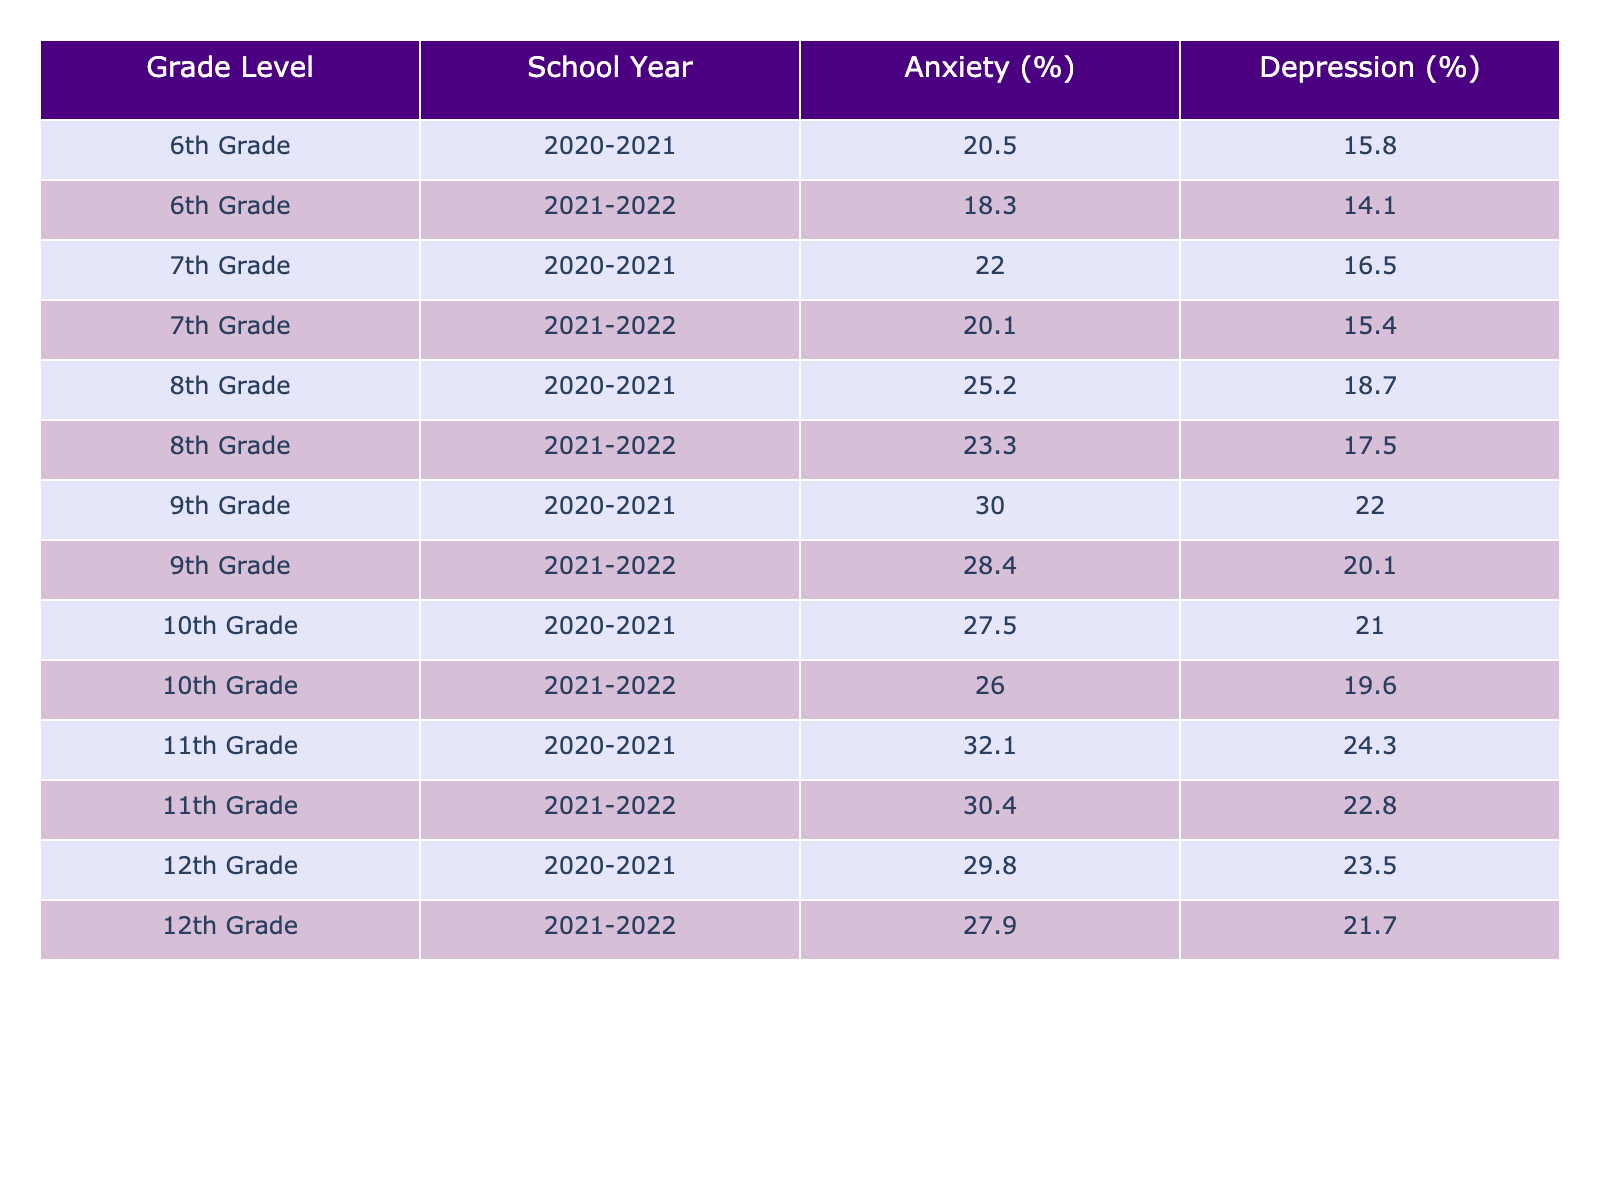What was the anxiety incidence rate for 9th graders in the school year 2020-2021? The table shows that for 9th graders in the school year 2020-2021, the anxiety incidence rate is listed as 30.0%.
Answer: 30.0% What is the difference in depression incidence rates between 11th graders in 2020-2021 and 2021-2022? The depression incidence rate for 11th graders in 2020-2021 is 24.3%, and in 2021-2022 it is 22.8%. The difference is 24.3% - 22.8% = 1.5%.
Answer: 1.5% What was the highest anxiety incidence rate, and which grade level and school year does it correspond to? The maximum anxiety incidence rate found in the table is 32.1%, corresponding to 11th graders in the school year 2020-2021.
Answer: 32.1% (11th Grade, 2020-2021) Is the depression incidence rate for 8th graders lower in 2021-2022 compared to 2020-2021? The table shows that the depression incidence rate for 8th graders is 18.7% in 2020-2021 and 17.5% in 2021-2022. Since 17.5% is lower than 18.7%, the answer is yes.
Answer: Yes What are the average anxiety and depression incidence rates for 12th graders over the two school years? For 12th graders, the anxiety rates are 29.8% and 27.9%, which average to (29.8 + 27.9) / 2 = 28.85%. The depression rates are 23.5% and 21.7%, averaging (23.5 + 21.7) / 2 = 22.6%. Therefore, the average anxiety rate is 28.85% and the average depression rate is 22.6%.
Answer: 28.85% (Anxiety), 22.6% (Depression) Did the overall incidence rates of anxiety increase or decrease from 2020-2021 to 2021-2022 for each grade level? Analyzing the data, 6th grade decreased from 20.5% to 18.3%, 7th grade decreased from 22.0% to 20.1%, 8th grade decreased from 25.2% to 23.3%, 9th grade decreased from 30.0% to 28.4%, 10th grade decreased from 27.5% to 26.0%, 11th grade decreased from 32.1% to 30.4%, and 12th grade decreased from 29.8% to 27.9%. All grade levels show a decrease in anxiety incidence rates.
Answer: Decrease What is the trend in the depression incidence rates for 10th graders from 2020-2021 to 2021-2022? For 10th graders, the depression incidence rate decreased from 21.0% in 2020-2021 to 19.6% in 2021-2022. This shows a downward trend.
Answer: Decrease Which grade level had the highest overall rates of anxiety and depression in 2021-2022? In 2021-2022, the highest anxiety incidence rate was 28.4% for 9th graders, and the highest depression incidence rate was 22.8% for 11th graders. Thus, 9th grade had the highest anxiety, and 11th grade had the highest depression.
Answer: 9th Grade (Anxiety), 11th Grade (Depression) What is the average reduction in anxiety rates from the first to the second year across all grades? The total anxiety rates for 2020-2021 sum up to 6 grades: 20.5 + 22.0 + 25.2 + 30.0 + 27.5 + 32.1 + 29.8 = 186.1%. The total for 2021-2022 is 18.3 + 20.1 + 23.3 + 28.4 + 26.0 + 30.4 + 27.9 = 174.4%. The reduction is 186.1% - 174.4% = 11.7%. To find the average reduction across the grades: 11.7% / 7 = approximately 1.67%.
Answer: 1.67% 